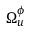Convert formula to latex. <formula><loc_0><loc_0><loc_500><loc_500>\Omega _ { u } ^ { \phi }</formula> 